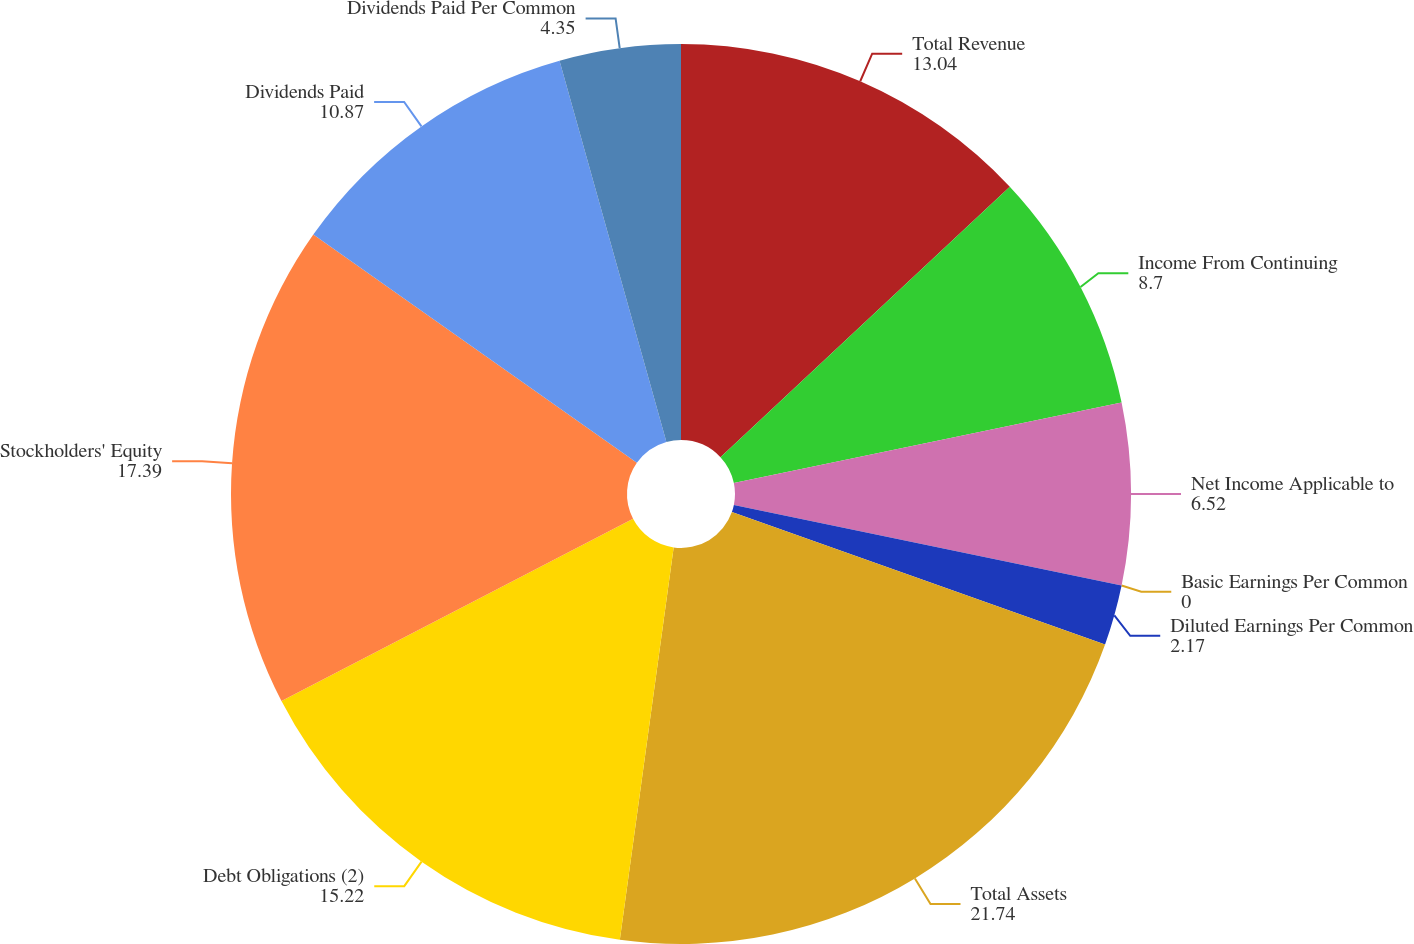Convert chart to OTSL. <chart><loc_0><loc_0><loc_500><loc_500><pie_chart><fcel>Total Revenue<fcel>Income From Continuing<fcel>Net Income Applicable to<fcel>Basic Earnings Per Common<fcel>Diluted Earnings Per Common<fcel>Total Assets<fcel>Debt Obligations (2)<fcel>Stockholders' Equity<fcel>Dividends Paid<fcel>Dividends Paid Per Common<nl><fcel>13.04%<fcel>8.7%<fcel>6.52%<fcel>0.0%<fcel>2.17%<fcel>21.74%<fcel>15.22%<fcel>17.39%<fcel>10.87%<fcel>4.35%<nl></chart> 